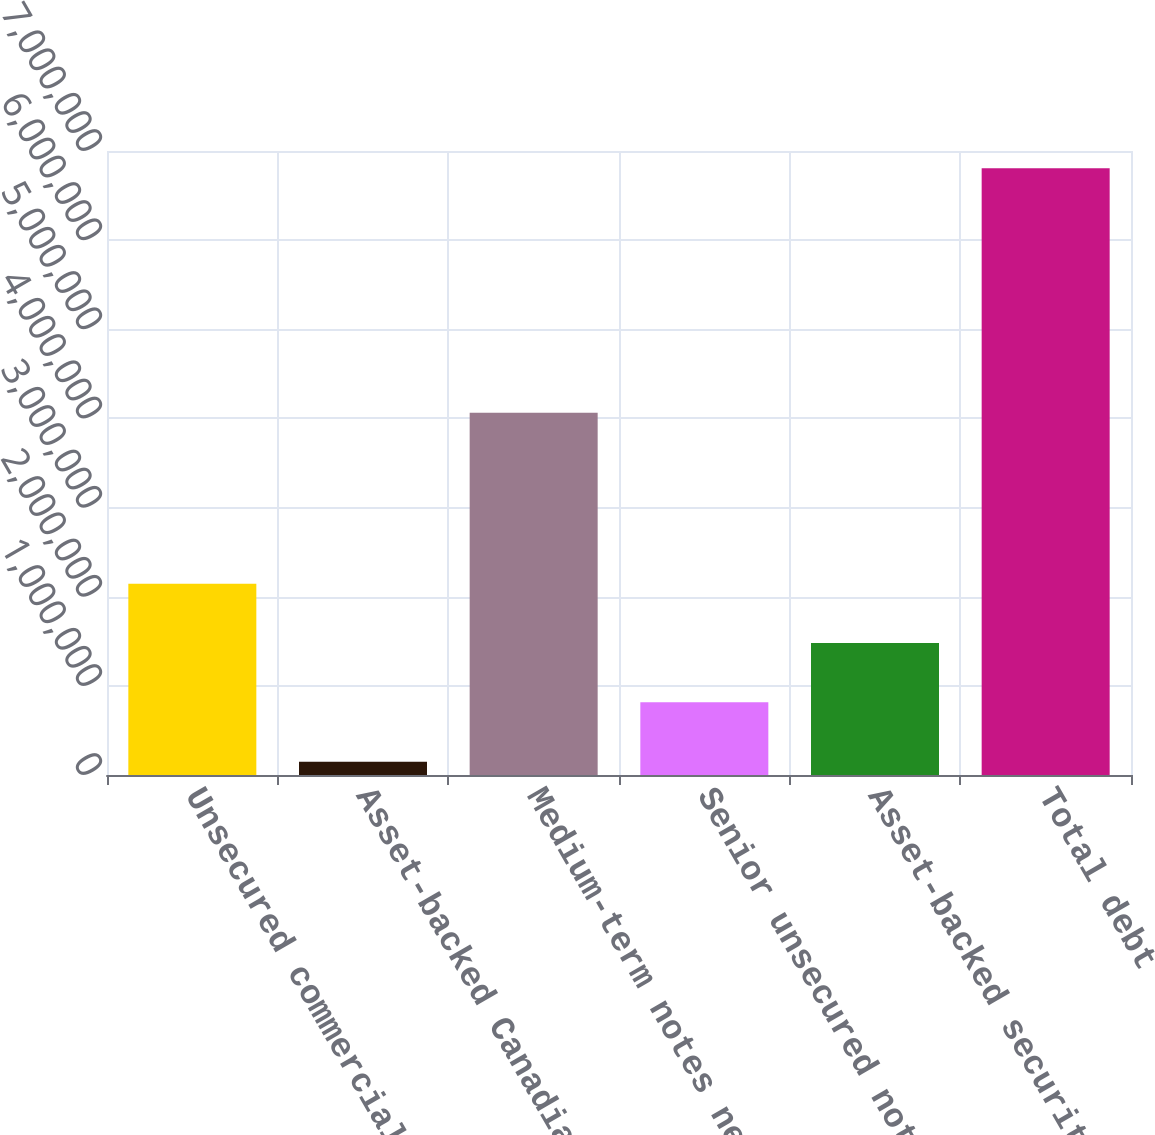Convert chart. <chart><loc_0><loc_0><loc_500><loc_500><bar_chart><fcel>Unsecured commercial paper<fcel>Asset-backed Canadian<fcel>Medium-term notes net<fcel>Senior unsecured notes net<fcel>Asset-backed securitization<fcel>Total debt<nl><fcel>2.14681e+06<fcel>149338<fcel>4.06494e+06<fcel>815161<fcel>1.48098e+06<fcel>6.80757e+06<nl></chart> 